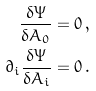Convert formula to latex. <formula><loc_0><loc_0><loc_500><loc_500>\frac { \delta \Psi } { \delta A _ { 0 } } & = 0 \, , \\ \partial _ { i } \frac { \delta \Psi } { \delta A _ { i } } & = 0 \, .</formula> 